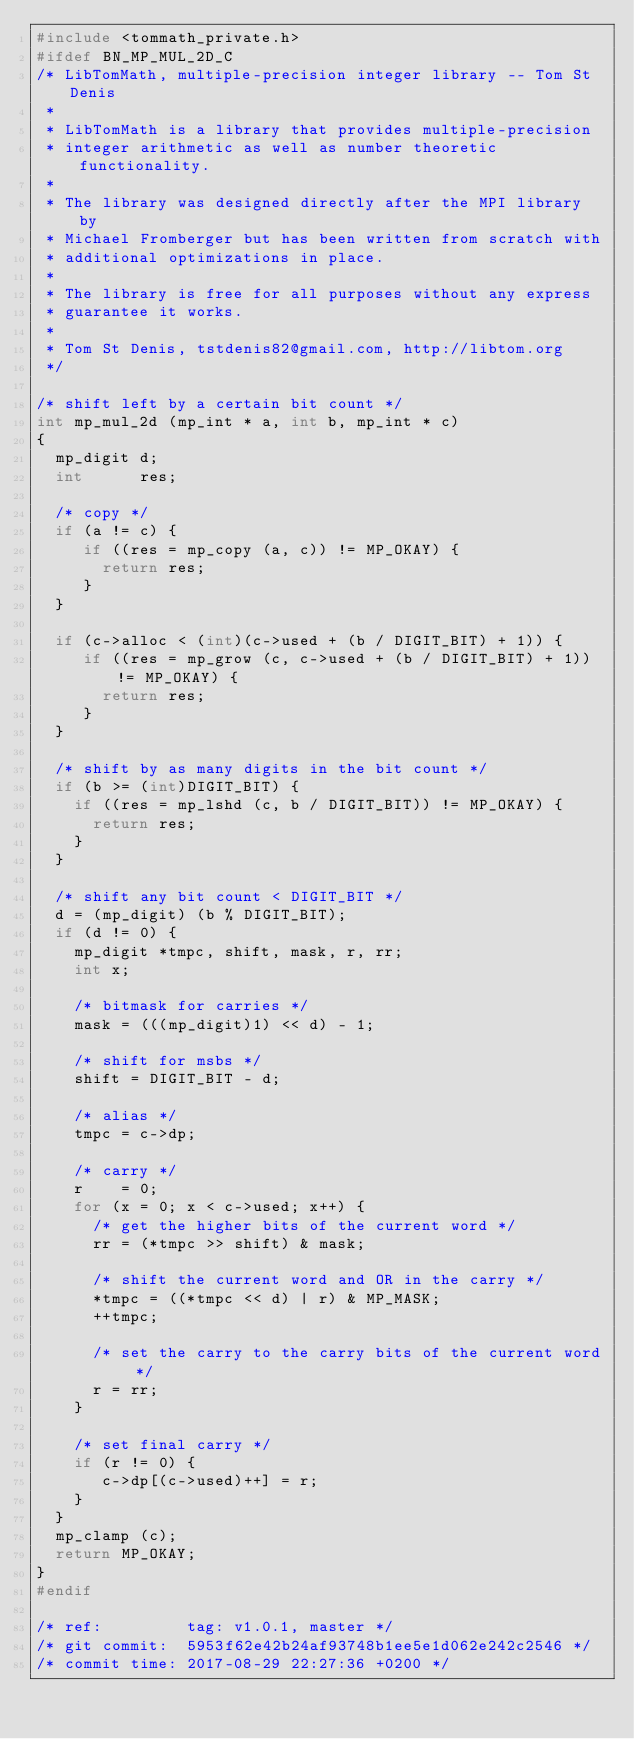<code> <loc_0><loc_0><loc_500><loc_500><_C_>#include <tommath_private.h>
#ifdef BN_MP_MUL_2D_C
/* LibTomMath, multiple-precision integer library -- Tom St Denis
 *
 * LibTomMath is a library that provides multiple-precision
 * integer arithmetic as well as number theoretic functionality.
 *
 * The library was designed directly after the MPI library by
 * Michael Fromberger but has been written from scratch with
 * additional optimizations in place.
 *
 * The library is free for all purposes without any express
 * guarantee it works.
 *
 * Tom St Denis, tstdenis82@gmail.com, http://libtom.org
 */

/* shift left by a certain bit count */
int mp_mul_2d (mp_int * a, int b, mp_int * c)
{
  mp_digit d;
  int      res;

  /* copy */
  if (a != c) {
     if ((res = mp_copy (a, c)) != MP_OKAY) {
       return res;
     }
  }

  if (c->alloc < (int)(c->used + (b / DIGIT_BIT) + 1)) {
     if ((res = mp_grow (c, c->used + (b / DIGIT_BIT) + 1)) != MP_OKAY) {
       return res;
     }
  }

  /* shift by as many digits in the bit count */
  if (b >= (int)DIGIT_BIT) {
    if ((res = mp_lshd (c, b / DIGIT_BIT)) != MP_OKAY) {
      return res;
    }
  }

  /* shift any bit count < DIGIT_BIT */
  d = (mp_digit) (b % DIGIT_BIT);
  if (d != 0) {
    mp_digit *tmpc, shift, mask, r, rr;
    int x;

    /* bitmask for carries */
    mask = (((mp_digit)1) << d) - 1;

    /* shift for msbs */
    shift = DIGIT_BIT - d;

    /* alias */
    tmpc = c->dp;

    /* carry */
    r    = 0;
    for (x = 0; x < c->used; x++) {
      /* get the higher bits of the current word */
      rr = (*tmpc >> shift) & mask;

      /* shift the current word and OR in the carry */
      *tmpc = ((*tmpc << d) | r) & MP_MASK;
      ++tmpc;

      /* set the carry to the carry bits of the current word */
      r = rr;
    }
    
    /* set final carry */
    if (r != 0) {
       c->dp[(c->used)++] = r;
    }
  }
  mp_clamp (c);
  return MP_OKAY;
}
#endif

/* ref:         tag: v1.0.1, master */
/* git commit:  5953f62e42b24af93748b1ee5e1d062e242c2546 */
/* commit time: 2017-08-29 22:27:36 +0200 */
</code> 